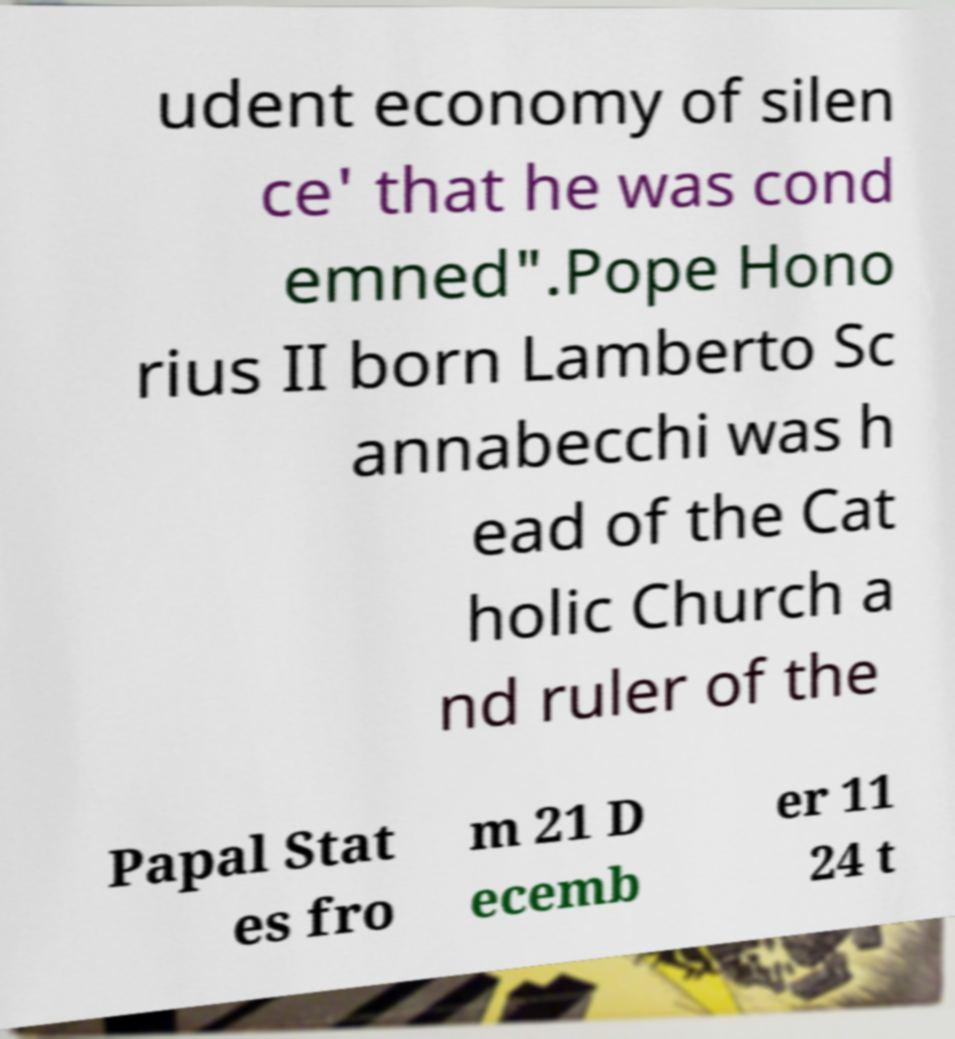What messages or text are displayed in this image? I need them in a readable, typed format. udent economy of silen ce' that he was cond emned".Pope Hono rius II born Lamberto Sc annabecchi was h ead of the Cat holic Church a nd ruler of the Papal Stat es fro m 21 D ecemb er 11 24 t 